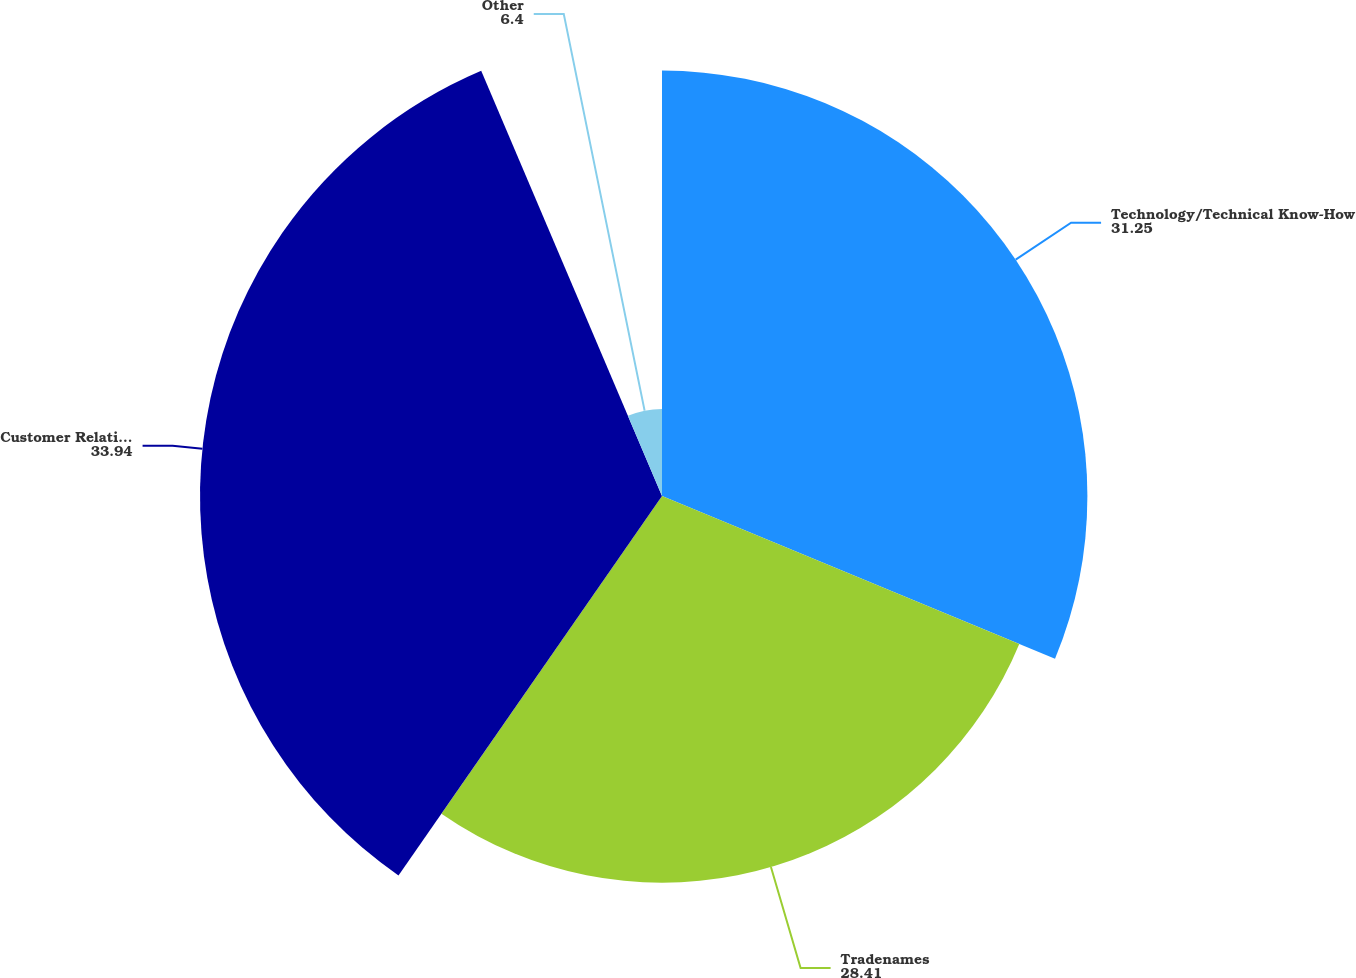Convert chart to OTSL. <chart><loc_0><loc_0><loc_500><loc_500><pie_chart><fcel>Technology/Technical Know-How<fcel>Tradenames<fcel>Customer Relationships<fcel>Other<nl><fcel>31.25%<fcel>28.41%<fcel>33.94%<fcel>6.4%<nl></chart> 